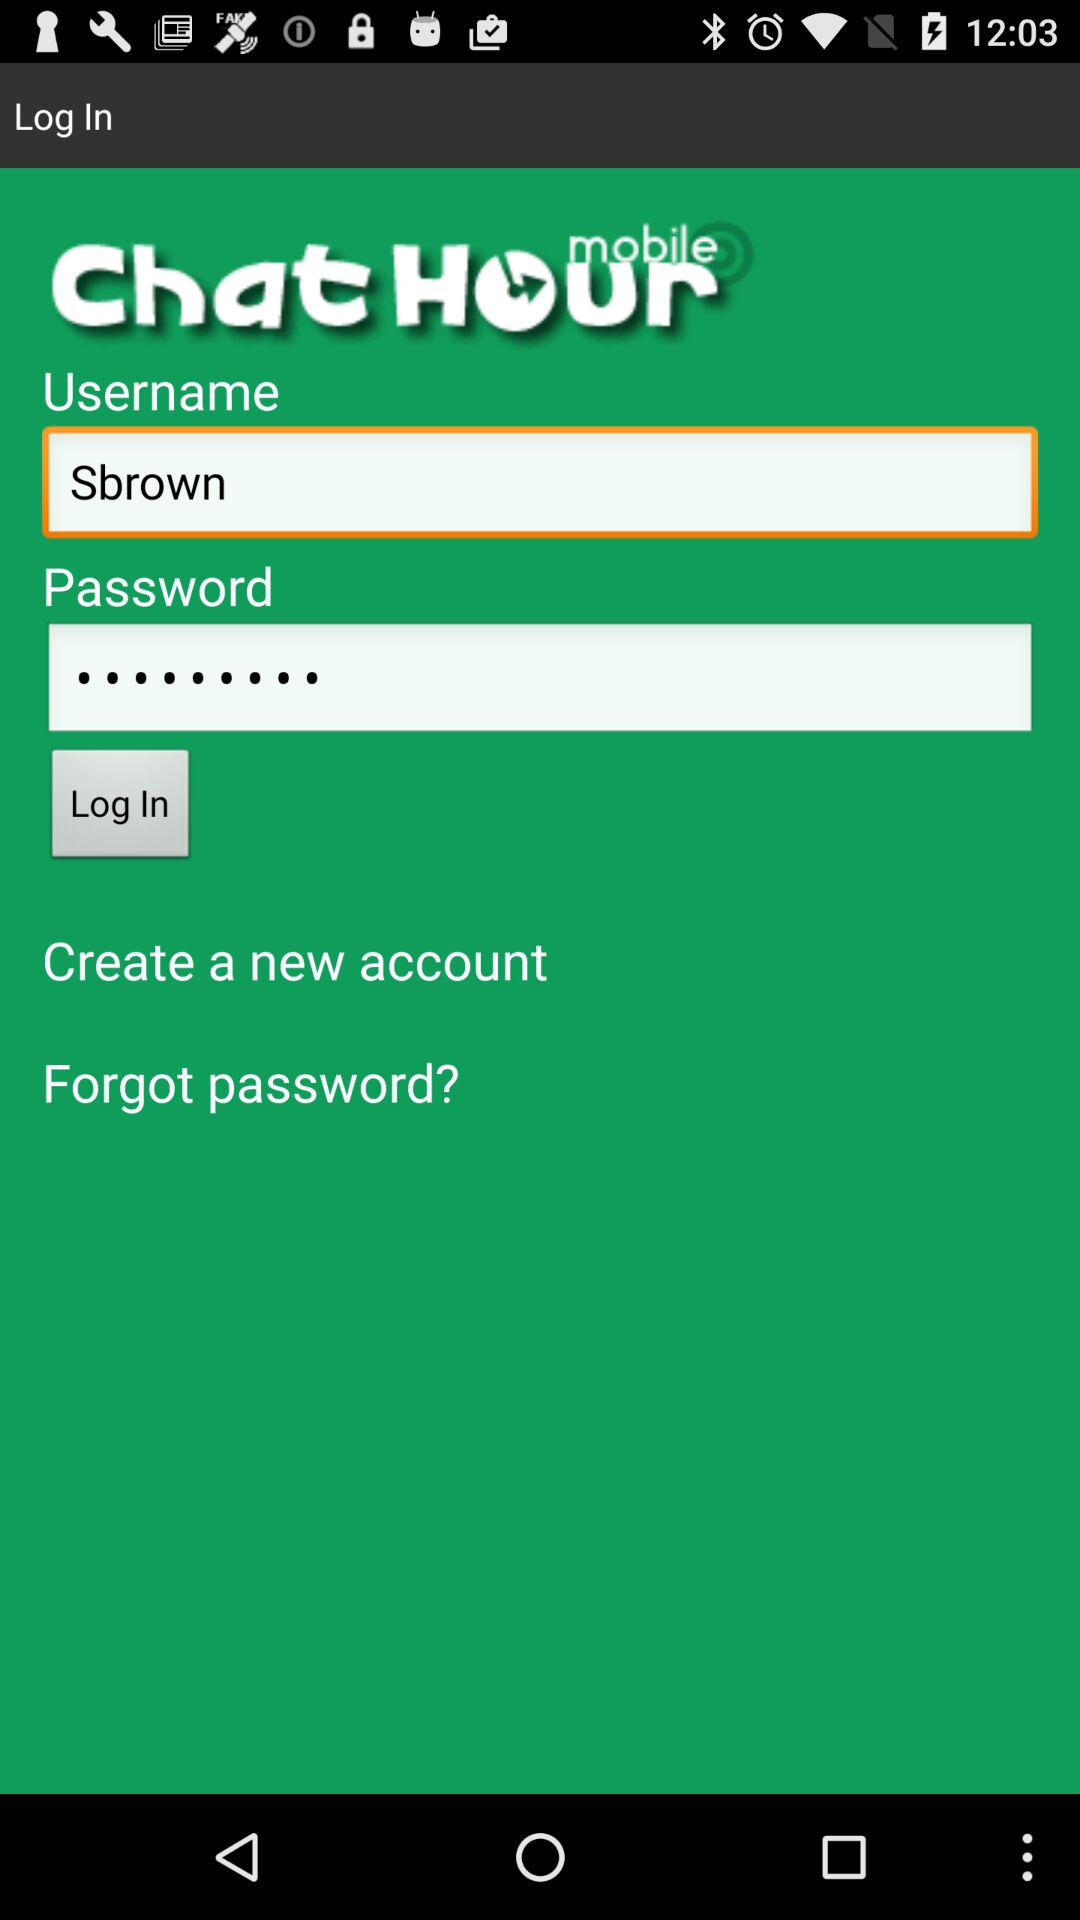What is the application name? The application name is "Chat Hour". 